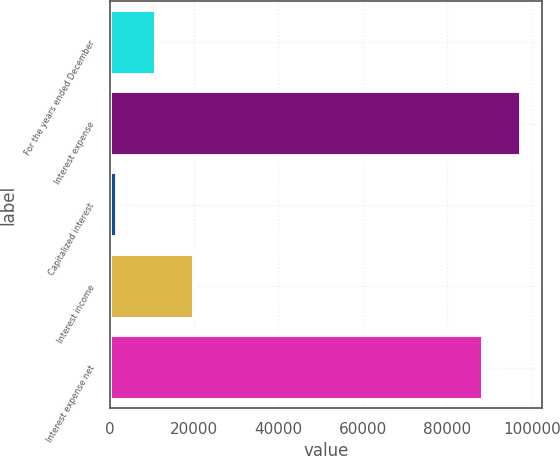<chart> <loc_0><loc_0><loc_500><loc_500><bar_chart><fcel>For the years ended December<fcel>Interest expense<fcel>Capitalized interest<fcel>Interest income<fcel>Interest expense net<nl><fcel>10895.4<fcel>97507.4<fcel>1744<fcel>20046.8<fcel>88356<nl></chart> 